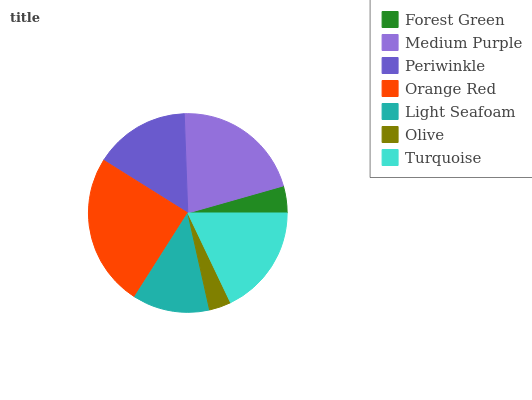Is Olive the minimum?
Answer yes or no. Yes. Is Orange Red the maximum?
Answer yes or no. Yes. Is Medium Purple the minimum?
Answer yes or no. No. Is Medium Purple the maximum?
Answer yes or no. No. Is Medium Purple greater than Forest Green?
Answer yes or no. Yes. Is Forest Green less than Medium Purple?
Answer yes or no. Yes. Is Forest Green greater than Medium Purple?
Answer yes or no. No. Is Medium Purple less than Forest Green?
Answer yes or no. No. Is Periwinkle the high median?
Answer yes or no. Yes. Is Periwinkle the low median?
Answer yes or no. Yes. Is Light Seafoam the high median?
Answer yes or no. No. Is Olive the low median?
Answer yes or no. No. 